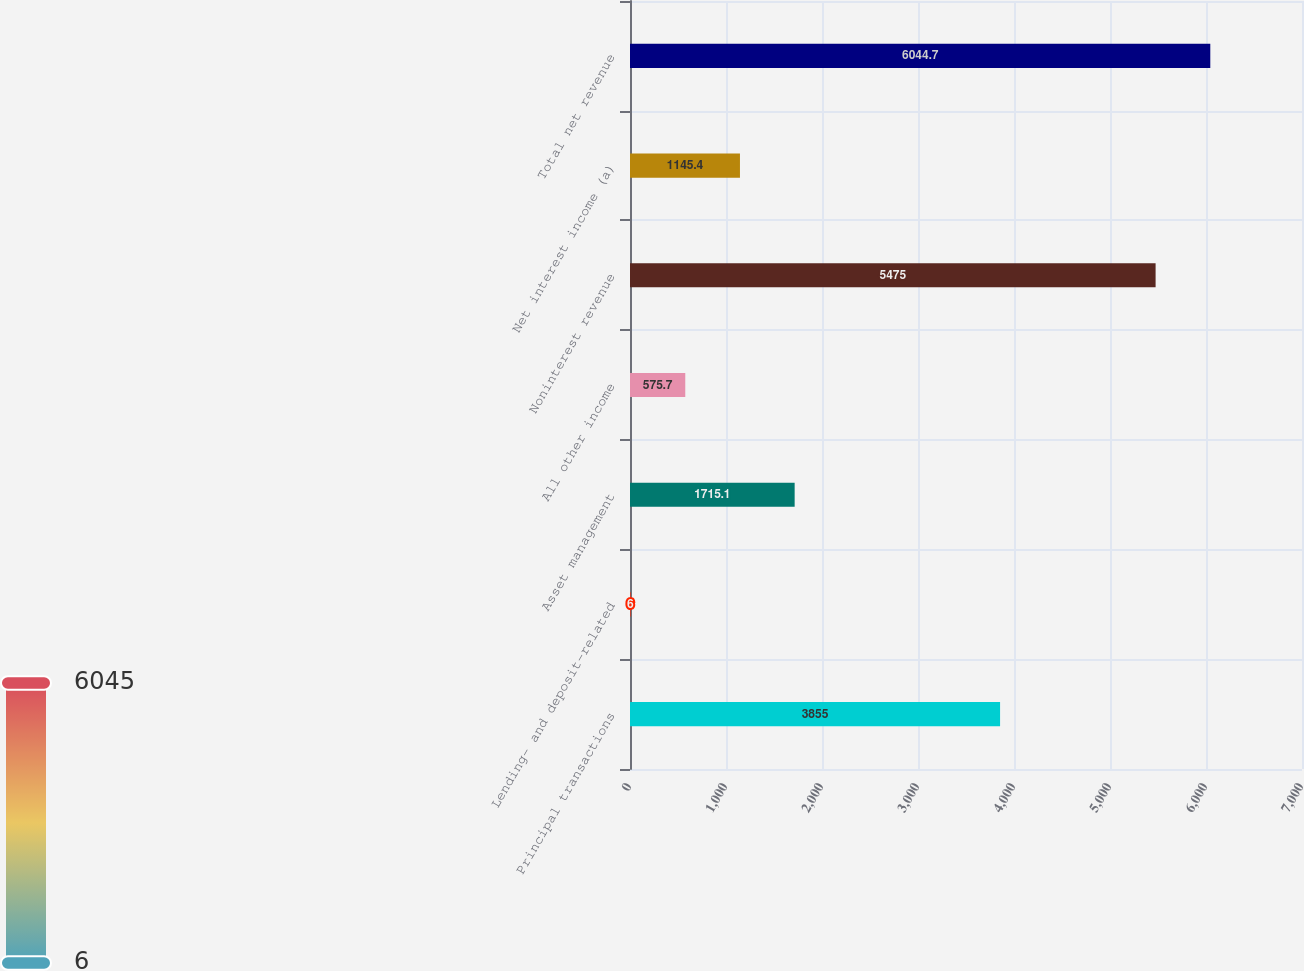<chart> <loc_0><loc_0><loc_500><loc_500><bar_chart><fcel>Principal transactions<fcel>Lending- and deposit-related<fcel>Asset management<fcel>All other income<fcel>Noninterest revenue<fcel>Net interest income (a)<fcel>Total net revenue<nl><fcel>3855<fcel>6<fcel>1715.1<fcel>575.7<fcel>5475<fcel>1145.4<fcel>6044.7<nl></chart> 